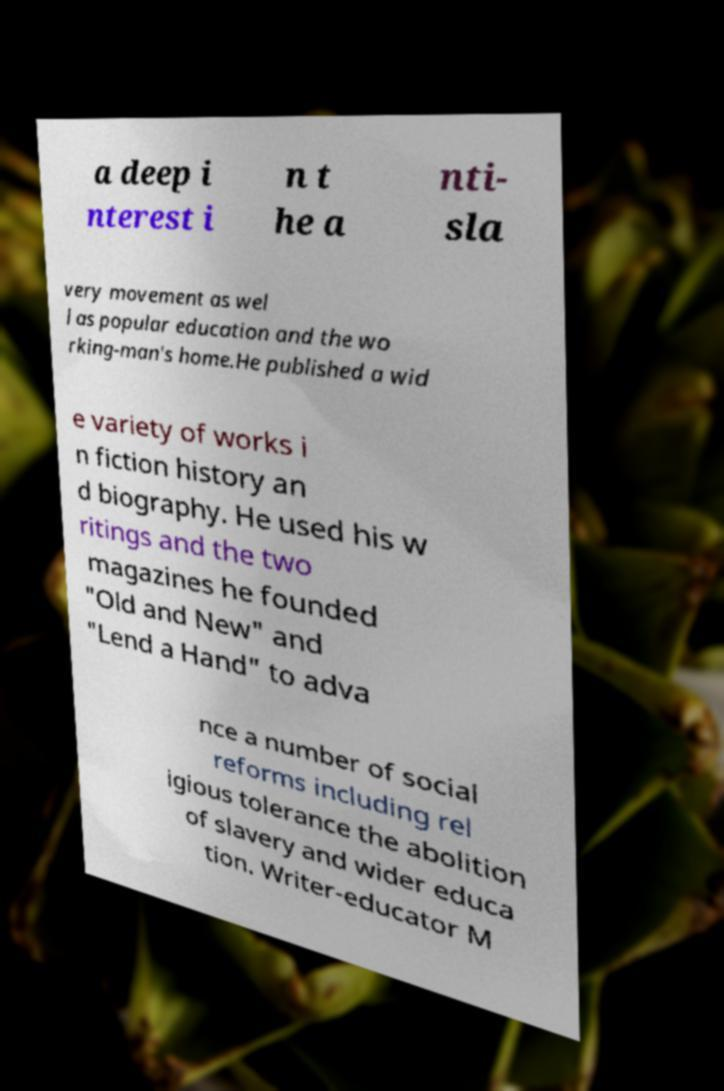Can you accurately transcribe the text from the provided image for me? a deep i nterest i n t he a nti- sla very movement as wel l as popular education and the wo rking-man's home.He published a wid e variety of works i n fiction history an d biography. He used his w ritings and the two magazines he founded "Old and New" and "Lend a Hand" to adva nce a number of social reforms including rel igious tolerance the abolition of slavery and wider educa tion. Writer-educator M 